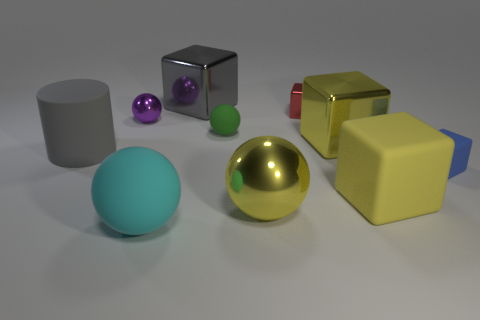Subtract all large cyan balls. How many balls are left? 3 Subtract all gray blocks. How many blocks are left? 4 Subtract all balls. How many objects are left? 6 Subtract 1 cubes. How many cubes are left? 4 Subtract all red balls. Subtract all brown cubes. How many balls are left? 4 Subtract all purple balls. How many blue blocks are left? 1 Subtract all large gray objects. Subtract all gray things. How many objects are left? 6 Add 3 green rubber objects. How many green rubber objects are left? 4 Add 5 yellow cubes. How many yellow cubes exist? 7 Subtract 2 yellow cubes. How many objects are left? 8 